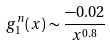<formula> <loc_0><loc_0><loc_500><loc_500>g _ { 1 } ^ { n } ( x ) \sim \frac { - 0 . 0 2 } { x ^ { 0 . 8 } }</formula> 